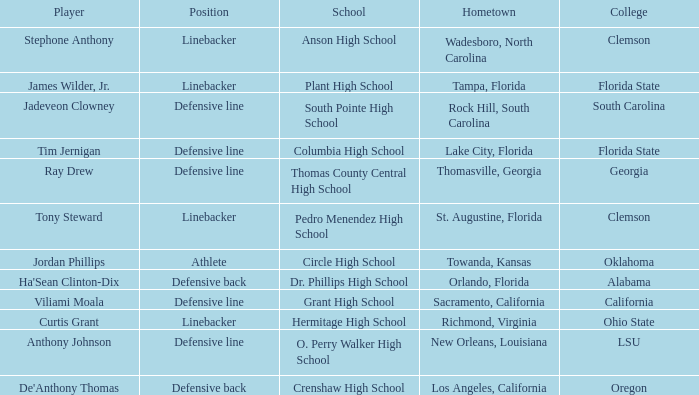Which hometown has a player of Ray Drew? Thomasville, Georgia. 